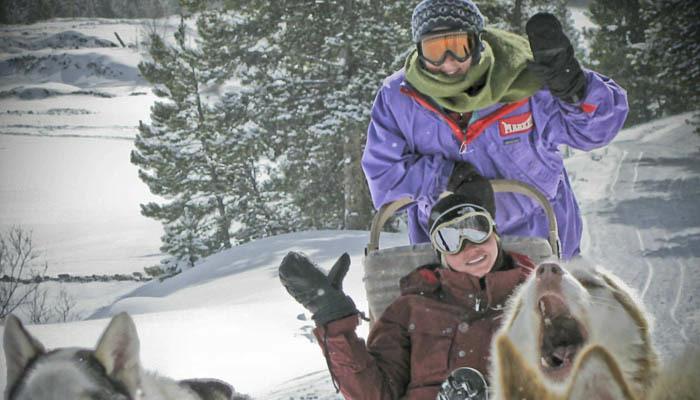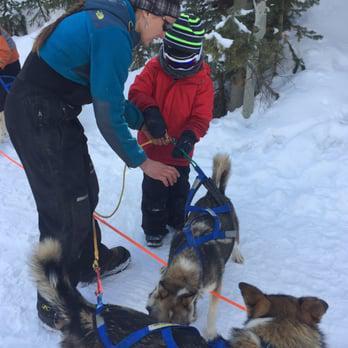The first image is the image on the left, the second image is the image on the right. Analyze the images presented: Is the assertion "A camera-facing person in winter clothing is hugging at least one dog to their front, and the dog's body is turned toward the camera too." valid? Answer yes or no. No. The first image is the image on the left, the second image is the image on the right. Evaluate the accuracy of this statement regarding the images: "There is one person holding at least one dog.". Is it true? Answer yes or no. No. 